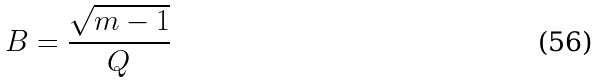Convert formula to latex. <formula><loc_0><loc_0><loc_500><loc_500>B = \frac { \sqrt { m - 1 } } { Q }</formula> 